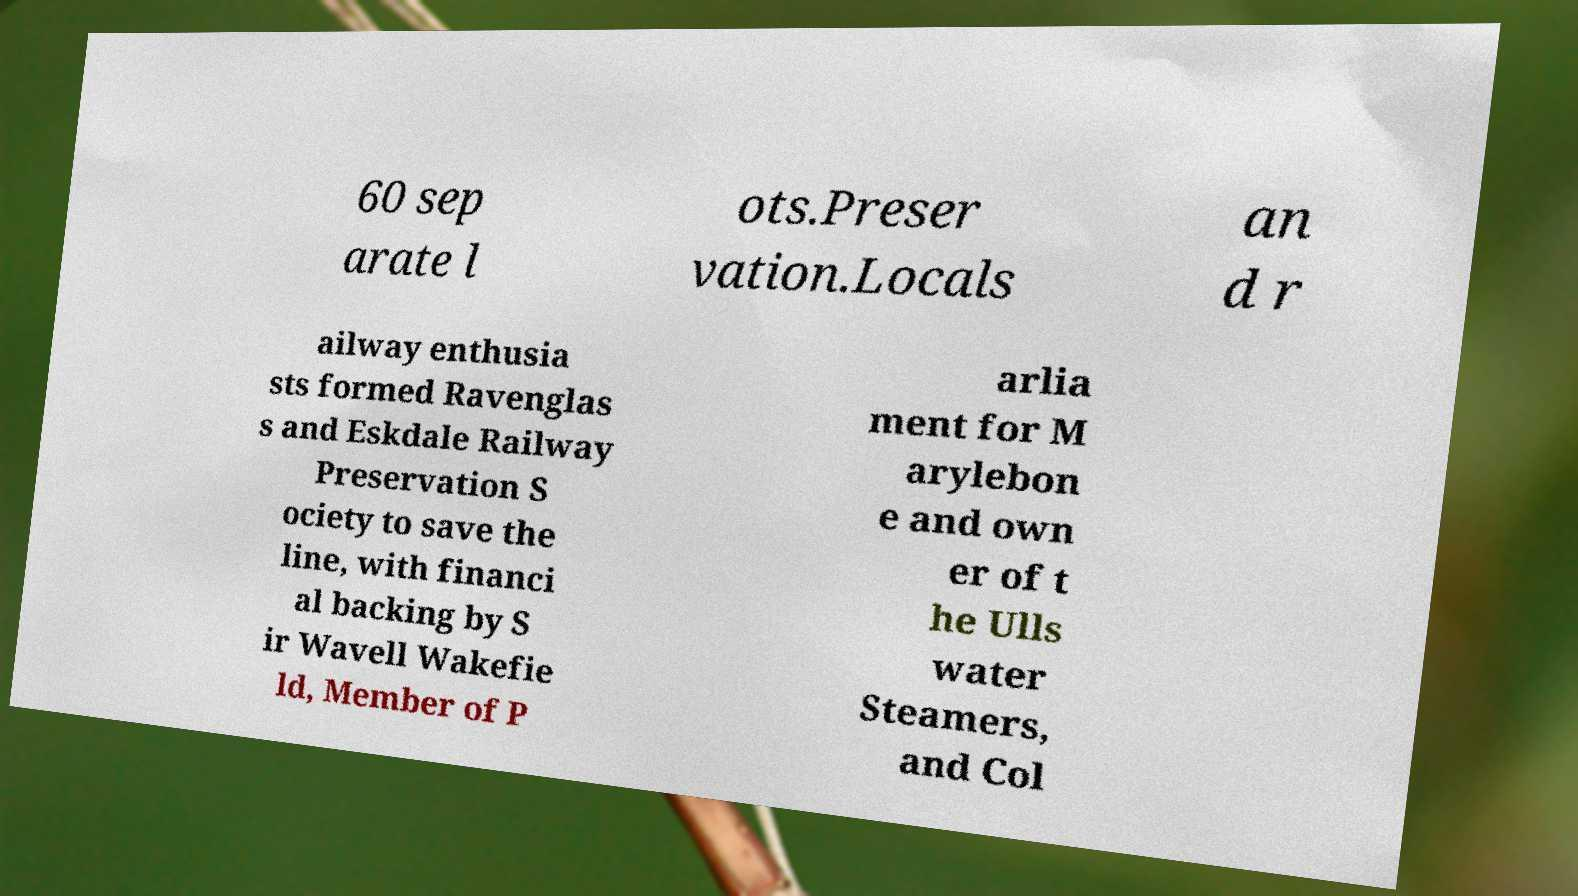What messages or text are displayed in this image? I need them in a readable, typed format. 60 sep arate l ots.Preser vation.Locals an d r ailway enthusia sts formed Ravenglas s and Eskdale Railway Preservation S ociety to save the line, with financi al backing by S ir Wavell Wakefie ld, Member of P arlia ment for M arylebon e and own er of t he Ulls water Steamers, and Col 